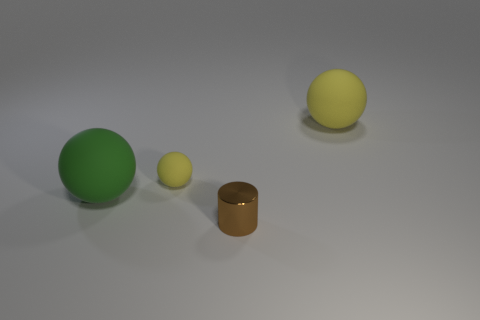Subtract all yellow spheres. How many spheres are left? 1 Add 4 tiny gray metal objects. How many objects exist? 8 Subtract all green balls. How many balls are left? 2 Subtract all spheres. How many objects are left? 1 Subtract all small shiny objects. Subtract all large spheres. How many objects are left? 1 Add 1 tiny yellow matte things. How many tiny yellow matte things are left? 2 Add 4 purple matte blocks. How many purple matte blocks exist? 4 Subtract 0 blue cylinders. How many objects are left? 4 Subtract 1 cylinders. How many cylinders are left? 0 Subtract all gray cylinders. Subtract all brown blocks. How many cylinders are left? 1 